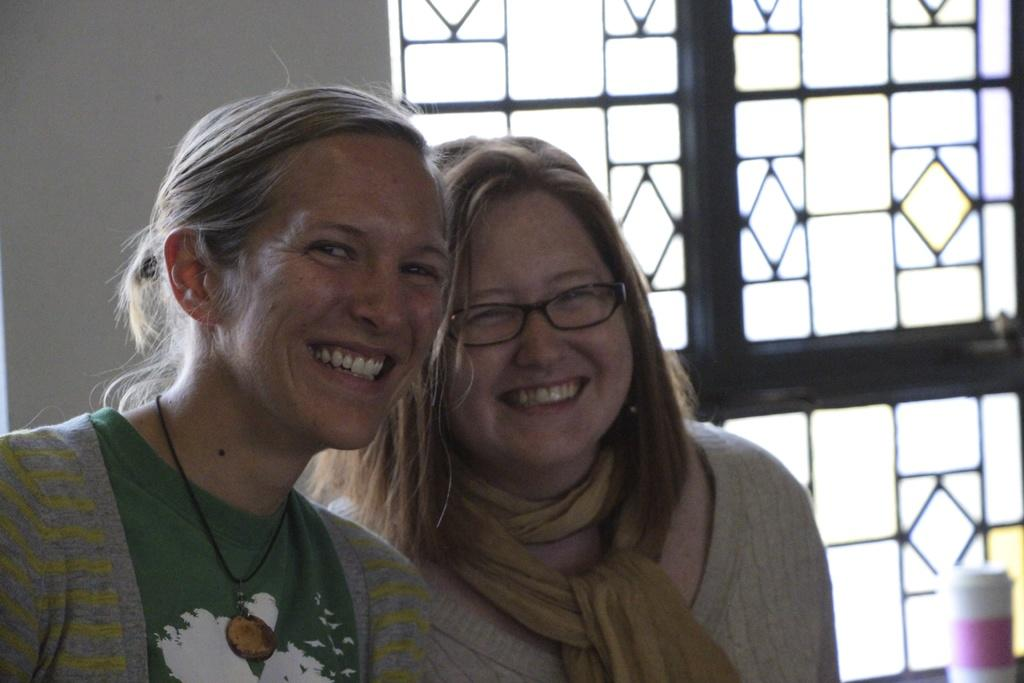How many people are in the foreground of the image? There are two ladies in the foreground of the image. What can be seen in the background of the image? There is a wall and a window with a grill in the background of the image. What type of produce is being sold through the window with a grill in the image? There is no produce visible in the image, as it only shows a wall and a window with a grill in the background. 